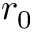Convert formula to latex. <formula><loc_0><loc_0><loc_500><loc_500>r _ { 0 }</formula> 